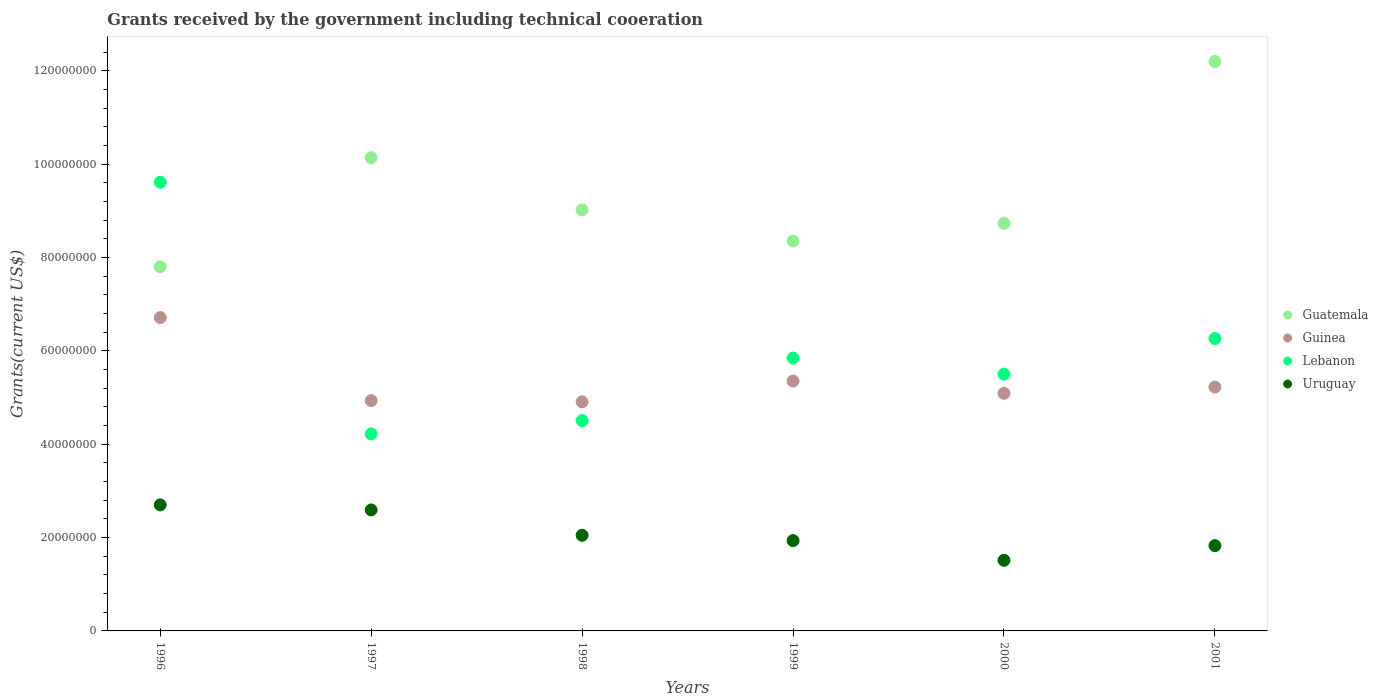How many different coloured dotlines are there?
Ensure brevity in your answer.  4. Is the number of dotlines equal to the number of legend labels?
Give a very brief answer. Yes. What is the total grants received by the government in Uruguay in 1996?
Provide a succinct answer. 2.70e+07. Across all years, what is the maximum total grants received by the government in Guatemala?
Provide a short and direct response. 1.22e+08. Across all years, what is the minimum total grants received by the government in Lebanon?
Provide a short and direct response. 4.22e+07. What is the total total grants received by the government in Lebanon in the graph?
Offer a very short reply. 3.60e+08. What is the difference between the total grants received by the government in Lebanon in 1999 and that in 2000?
Offer a very short reply. 3.45e+06. What is the difference between the total grants received by the government in Guatemala in 1998 and the total grants received by the government in Lebanon in 1996?
Your answer should be compact. -5.93e+06. What is the average total grants received by the government in Guatemala per year?
Keep it short and to the point. 9.37e+07. In the year 2000, what is the difference between the total grants received by the government in Guatemala and total grants received by the government in Guinea?
Provide a short and direct response. 3.64e+07. In how many years, is the total grants received by the government in Uruguay greater than 72000000 US$?
Give a very brief answer. 0. What is the ratio of the total grants received by the government in Guatemala in 1997 to that in 2000?
Provide a short and direct response. 1.16. What is the difference between the highest and the second highest total grants received by the government in Guatemala?
Ensure brevity in your answer.  2.06e+07. What is the difference between the highest and the lowest total grants received by the government in Uruguay?
Provide a succinct answer. 1.19e+07. In how many years, is the total grants received by the government in Lebanon greater than the average total grants received by the government in Lebanon taken over all years?
Your response must be concise. 2. Is the sum of the total grants received by the government in Uruguay in 1998 and 2001 greater than the maximum total grants received by the government in Guatemala across all years?
Give a very brief answer. No. Is it the case that in every year, the sum of the total grants received by the government in Lebanon and total grants received by the government in Guinea  is greater than the sum of total grants received by the government in Uruguay and total grants received by the government in Guatemala?
Give a very brief answer. No. How many dotlines are there?
Make the answer very short. 4. What is the difference between two consecutive major ticks on the Y-axis?
Keep it short and to the point. 2.00e+07. Does the graph contain any zero values?
Keep it short and to the point. No. Does the graph contain grids?
Make the answer very short. No. How are the legend labels stacked?
Provide a short and direct response. Vertical. What is the title of the graph?
Make the answer very short. Grants received by the government including technical cooeration. Does "Jamaica" appear as one of the legend labels in the graph?
Your response must be concise. No. What is the label or title of the Y-axis?
Give a very brief answer. Grants(current US$). What is the Grants(current US$) in Guatemala in 1996?
Ensure brevity in your answer.  7.80e+07. What is the Grants(current US$) of Guinea in 1996?
Ensure brevity in your answer.  6.71e+07. What is the Grants(current US$) in Lebanon in 1996?
Offer a very short reply. 9.61e+07. What is the Grants(current US$) of Uruguay in 1996?
Make the answer very short. 2.70e+07. What is the Grants(current US$) of Guatemala in 1997?
Your answer should be very brief. 1.01e+08. What is the Grants(current US$) of Guinea in 1997?
Offer a very short reply. 4.93e+07. What is the Grants(current US$) of Lebanon in 1997?
Provide a succinct answer. 4.22e+07. What is the Grants(current US$) of Uruguay in 1997?
Give a very brief answer. 2.59e+07. What is the Grants(current US$) of Guatemala in 1998?
Ensure brevity in your answer.  9.02e+07. What is the Grants(current US$) in Guinea in 1998?
Your answer should be compact. 4.91e+07. What is the Grants(current US$) of Lebanon in 1998?
Offer a very short reply. 4.51e+07. What is the Grants(current US$) in Uruguay in 1998?
Provide a short and direct response. 2.05e+07. What is the Grants(current US$) in Guatemala in 1999?
Provide a short and direct response. 8.35e+07. What is the Grants(current US$) in Guinea in 1999?
Your answer should be very brief. 5.35e+07. What is the Grants(current US$) in Lebanon in 1999?
Provide a short and direct response. 5.85e+07. What is the Grants(current US$) in Uruguay in 1999?
Offer a very short reply. 1.94e+07. What is the Grants(current US$) of Guatemala in 2000?
Your response must be concise. 8.73e+07. What is the Grants(current US$) in Guinea in 2000?
Give a very brief answer. 5.09e+07. What is the Grants(current US$) of Lebanon in 2000?
Your answer should be very brief. 5.50e+07. What is the Grants(current US$) in Uruguay in 2000?
Provide a succinct answer. 1.51e+07. What is the Grants(current US$) in Guatemala in 2001?
Your answer should be compact. 1.22e+08. What is the Grants(current US$) of Guinea in 2001?
Offer a very short reply. 5.22e+07. What is the Grants(current US$) in Lebanon in 2001?
Your answer should be very brief. 6.26e+07. What is the Grants(current US$) in Uruguay in 2001?
Offer a very short reply. 1.83e+07. Across all years, what is the maximum Grants(current US$) of Guatemala?
Ensure brevity in your answer.  1.22e+08. Across all years, what is the maximum Grants(current US$) in Guinea?
Provide a succinct answer. 6.71e+07. Across all years, what is the maximum Grants(current US$) of Lebanon?
Make the answer very short. 9.61e+07. Across all years, what is the maximum Grants(current US$) of Uruguay?
Give a very brief answer. 2.70e+07. Across all years, what is the minimum Grants(current US$) in Guatemala?
Your response must be concise. 7.80e+07. Across all years, what is the minimum Grants(current US$) in Guinea?
Offer a very short reply. 4.91e+07. Across all years, what is the minimum Grants(current US$) in Lebanon?
Offer a very short reply. 4.22e+07. Across all years, what is the minimum Grants(current US$) in Uruguay?
Your answer should be compact. 1.51e+07. What is the total Grants(current US$) in Guatemala in the graph?
Offer a terse response. 5.62e+08. What is the total Grants(current US$) of Guinea in the graph?
Your answer should be compact. 3.22e+08. What is the total Grants(current US$) in Lebanon in the graph?
Give a very brief answer. 3.60e+08. What is the total Grants(current US$) in Uruguay in the graph?
Make the answer very short. 1.26e+08. What is the difference between the Grants(current US$) in Guatemala in 1996 and that in 1997?
Provide a short and direct response. -2.34e+07. What is the difference between the Grants(current US$) of Guinea in 1996 and that in 1997?
Your answer should be very brief. 1.78e+07. What is the difference between the Grants(current US$) of Lebanon in 1996 and that in 1997?
Provide a short and direct response. 5.39e+07. What is the difference between the Grants(current US$) in Uruguay in 1996 and that in 1997?
Make the answer very short. 1.08e+06. What is the difference between the Grants(current US$) of Guatemala in 1996 and that in 1998?
Give a very brief answer. -1.22e+07. What is the difference between the Grants(current US$) of Guinea in 1996 and that in 1998?
Offer a very short reply. 1.80e+07. What is the difference between the Grants(current US$) of Lebanon in 1996 and that in 1998?
Give a very brief answer. 5.11e+07. What is the difference between the Grants(current US$) in Uruguay in 1996 and that in 1998?
Provide a short and direct response. 6.51e+06. What is the difference between the Grants(current US$) in Guatemala in 1996 and that in 1999?
Offer a very short reply. -5.51e+06. What is the difference between the Grants(current US$) of Guinea in 1996 and that in 1999?
Provide a succinct answer. 1.36e+07. What is the difference between the Grants(current US$) in Lebanon in 1996 and that in 1999?
Provide a succinct answer. 3.77e+07. What is the difference between the Grants(current US$) of Uruguay in 1996 and that in 1999?
Offer a terse response. 7.65e+06. What is the difference between the Grants(current US$) of Guatemala in 1996 and that in 2000?
Offer a very short reply. -9.30e+06. What is the difference between the Grants(current US$) in Guinea in 1996 and that in 2000?
Keep it short and to the point. 1.62e+07. What is the difference between the Grants(current US$) of Lebanon in 1996 and that in 2000?
Your answer should be very brief. 4.11e+07. What is the difference between the Grants(current US$) of Uruguay in 1996 and that in 2000?
Make the answer very short. 1.19e+07. What is the difference between the Grants(current US$) in Guatemala in 1996 and that in 2001?
Ensure brevity in your answer.  -4.40e+07. What is the difference between the Grants(current US$) of Guinea in 1996 and that in 2001?
Ensure brevity in your answer.  1.49e+07. What is the difference between the Grants(current US$) in Lebanon in 1996 and that in 2001?
Offer a terse response. 3.35e+07. What is the difference between the Grants(current US$) of Uruguay in 1996 and that in 2001?
Your response must be concise. 8.73e+06. What is the difference between the Grants(current US$) in Guatemala in 1997 and that in 1998?
Make the answer very short. 1.12e+07. What is the difference between the Grants(current US$) of Guinea in 1997 and that in 1998?
Your answer should be compact. 2.60e+05. What is the difference between the Grants(current US$) of Lebanon in 1997 and that in 1998?
Provide a succinct answer. -2.85e+06. What is the difference between the Grants(current US$) in Uruguay in 1997 and that in 1998?
Your response must be concise. 5.43e+06. What is the difference between the Grants(current US$) in Guatemala in 1997 and that in 1999?
Your answer should be compact. 1.78e+07. What is the difference between the Grants(current US$) of Guinea in 1997 and that in 1999?
Provide a succinct answer. -4.19e+06. What is the difference between the Grants(current US$) in Lebanon in 1997 and that in 1999?
Keep it short and to the point. -1.63e+07. What is the difference between the Grants(current US$) in Uruguay in 1997 and that in 1999?
Give a very brief answer. 6.57e+06. What is the difference between the Grants(current US$) of Guatemala in 1997 and that in 2000?
Provide a short and direct response. 1.41e+07. What is the difference between the Grants(current US$) of Guinea in 1997 and that in 2000?
Offer a very short reply. -1.56e+06. What is the difference between the Grants(current US$) of Lebanon in 1997 and that in 2000?
Your response must be concise. -1.28e+07. What is the difference between the Grants(current US$) of Uruguay in 1997 and that in 2000?
Your answer should be compact. 1.08e+07. What is the difference between the Grants(current US$) in Guatemala in 1997 and that in 2001?
Provide a short and direct response. -2.06e+07. What is the difference between the Grants(current US$) in Guinea in 1997 and that in 2001?
Provide a short and direct response. -2.91e+06. What is the difference between the Grants(current US$) in Lebanon in 1997 and that in 2001?
Give a very brief answer. -2.04e+07. What is the difference between the Grants(current US$) in Uruguay in 1997 and that in 2001?
Your response must be concise. 7.65e+06. What is the difference between the Grants(current US$) of Guatemala in 1998 and that in 1999?
Give a very brief answer. 6.67e+06. What is the difference between the Grants(current US$) in Guinea in 1998 and that in 1999?
Offer a very short reply. -4.45e+06. What is the difference between the Grants(current US$) in Lebanon in 1998 and that in 1999?
Your answer should be compact. -1.34e+07. What is the difference between the Grants(current US$) in Uruguay in 1998 and that in 1999?
Provide a succinct answer. 1.14e+06. What is the difference between the Grants(current US$) of Guatemala in 1998 and that in 2000?
Give a very brief answer. 2.88e+06. What is the difference between the Grants(current US$) in Guinea in 1998 and that in 2000?
Your response must be concise. -1.82e+06. What is the difference between the Grants(current US$) of Lebanon in 1998 and that in 2000?
Keep it short and to the point. -9.96e+06. What is the difference between the Grants(current US$) in Uruguay in 1998 and that in 2000?
Give a very brief answer. 5.36e+06. What is the difference between the Grants(current US$) in Guatemala in 1998 and that in 2001?
Make the answer very short. -3.18e+07. What is the difference between the Grants(current US$) in Guinea in 1998 and that in 2001?
Make the answer very short. -3.17e+06. What is the difference between the Grants(current US$) in Lebanon in 1998 and that in 2001?
Keep it short and to the point. -1.76e+07. What is the difference between the Grants(current US$) of Uruguay in 1998 and that in 2001?
Offer a very short reply. 2.22e+06. What is the difference between the Grants(current US$) in Guatemala in 1999 and that in 2000?
Ensure brevity in your answer.  -3.79e+06. What is the difference between the Grants(current US$) of Guinea in 1999 and that in 2000?
Offer a very short reply. 2.63e+06. What is the difference between the Grants(current US$) in Lebanon in 1999 and that in 2000?
Ensure brevity in your answer.  3.45e+06. What is the difference between the Grants(current US$) of Uruguay in 1999 and that in 2000?
Offer a very short reply. 4.22e+06. What is the difference between the Grants(current US$) in Guatemala in 1999 and that in 2001?
Offer a terse response. -3.85e+07. What is the difference between the Grants(current US$) of Guinea in 1999 and that in 2001?
Offer a very short reply. 1.28e+06. What is the difference between the Grants(current US$) of Lebanon in 1999 and that in 2001?
Provide a succinct answer. -4.17e+06. What is the difference between the Grants(current US$) of Uruguay in 1999 and that in 2001?
Keep it short and to the point. 1.08e+06. What is the difference between the Grants(current US$) of Guatemala in 2000 and that in 2001?
Make the answer very short. -3.47e+07. What is the difference between the Grants(current US$) in Guinea in 2000 and that in 2001?
Keep it short and to the point. -1.35e+06. What is the difference between the Grants(current US$) of Lebanon in 2000 and that in 2001?
Give a very brief answer. -7.62e+06. What is the difference between the Grants(current US$) in Uruguay in 2000 and that in 2001?
Give a very brief answer. -3.14e+06. What is the difference between the Grants(current US$) in Guatemala in 1996 and the Grants(current US$) in Guinea in 1997?
Offer a very short reply. 2.87e+07. What is the difference between the Grants(current US$) of Guatemala in 1996 and the Grants(current US$) of Lebanon in 1997?
Your answer should be compact. 3.58e+07. What is the difference between the Grants(current US$) in Guatemala in 1996 and the Grants(current US$) in Uruguay in 1997?
Ensure brevity in your answer.  5.21e+07. What is the difference between the Grants(current US$) in Guinea in 1996 and the Grants(current US$) in Lebanon in 1997?
Give a very brief answer. 2.49e+07. What is the difference between the Grants(current US$) of Guinea in 1996 and the Grants(current US$) of Uruguay in 1997?
Provide a succinct answer. 4.12e+07. What is the difference between the Grants(current US$) of Lebanon in 1996 and the Grants(current US$) of Uruguay in 1997?
Provide a short and direct response. 7.02e+07. What is the difference between the Grants(current US$) of Guatemala in 1996 and the Grants(current US$) of Guinea in 1998?
Offer a terse response. 2.89e+07. What is the difference between the Grants(current US$) in Guatemala in 1996 and the Grants(current US$) in Lebanon in 1998?
Your response must be concise. 3.30e+07. What is the difference between the Grants(current US$) in Guatemala in 1996 and the Grants(current US$) in Uruguay in 1998?
Your response must be concise. 5.75e+07. What is the difference between the Grants(current US$) of Guinea in 1996 and the Grants(current US$) of Lebanon in 1998?
Give a very brief answer. 2.21e+07. What is the difference between the Grants(current US$) in Guinea in 1996 and the Grants(current US$) in Uruguay in 1998?
Provide a succinct answer. 4.66e+07. What is the difference between the Grants(current US$) of Lebanon in 1996 and the Grants(current US$) of Uruguay in 1998?
Keep it short and to the point. 7.56e+07. What is the difference between the Grants(current US$) of Guatemala in 1996 and the Grants(current US$) of Guinea in 1999?
Your answer should be very brief. 2.45e+07. What is the difference between the Grants(current US$) of Guatemala in 1996 and the Grants(current US$) of Lebanon in 1999?
Offer a terse response. 1.96e+07. What is the difference between the Grants(current US$) of Guatemala in 1996 and the Grants(current US$) of Uruguay in 1999?
Offer a very short reply. 5.87e+07. What is the difference between the Grants(current US$) of Guinea in 1996 and the Grants(current US$) of Lebanon in 1999?
Keep it short and to the point. 8.66e+06. What is the difference between the Grants(current US$) of Guinea in 1996 and the Grants(current US$) of Uruguay in 1999?
Offer a very short reply. 4.78e+07. What is the difference between the Grants(current US$) of Lebanon in 1996 and the Grants(current US$) of Uruguay in 1999?
Your answer should be very brief. 7.68e+07. What is the difference between the Grants(current US$) of Guatemala in 1996 and the Grants(current US$) of Guinea in 2000?
Offer a very short reply. 2.71e+07. What is the difference between the Grants(current US$) of Guatemala in 1996 and the Grants(current US$) of Lebanon in 2000?
Provide a succinct answer. 2.30e+07. What is the difference between the Grants(current US$) in Guatemala in 1996 and the Grants(current US$) in Uruguay in 2000?
Your answer should be very brief. 6.29e+07. What is the difference between the Grants(current US$) of Guinea in 1996 and the Grants(current US$) of Lebanon in 2000?
Make the answer very short. 1.21e+07. What is the difference between the Grants(current US$) in Guinea in 1996 and the Grants(current US$) in Uruguay in 2000?
Provide a short and direct response. 5.20e+07. What is the difference between the Grants(current US$) of Lebanon in 1996 and the Grants(current US$) of Uruguay in 2000?
Ensure brevity in your answer.  8.10e+07. What is the difference between the Grants(current US$) of Guatemala in 1996 and the Grants(current US$) of Guinea in 2001?
Your response must be concise. 2.58e+07. What is the difference between the Grants(current US$) in Guatemala in 1996 and the Grants(current US$) in Lebanon in 2001?
Your answer should be compact. 1.54e+07. What is the difference between the Grants(current US$) in Guatemala in 1996 and the Grants(current US$) in Uruguay in 2001?
Your answer should be very brief. 5.98e+07. What is the difference between the Grants(current US$) in Guinea in 1996 and the Grants(current US$) in Lebanon in 2001?
Your response must be concise. 4.49e+06. What is the difference between the Grants(current US$) in Guinea in 1996 and the Grants(current US$) in Uruguay in 2001?
Provide a short and direct response. 4.89e+07. What is the difference between the Grants(current US$) of Lebanon in 1996 and the Grants(current US$) of Uruguay in 2001?
Keep it short and to the point. 7.79e+07. What is the difference between the Grants(current US$) in Guatemala in 1997 and the Grants(current US$) in Guinea in 1998?
Offer a very short reply. 5.23e+07. What is the difference between the Grants(current US$) in Guatemala in 1997 and the Grants(current US$) in Lebanon in 1998?
Make the answer very short. 5.63e+07. What is the difference between the Grants(current US$) of Guatemala in 1997 and the Grants(current US$) of Uruguay in 1998?
Give a very brief answer. 8.09e+07. What is the difference between the Grants(current US$) in Guinea in 1997 and the Grants(current US$) in Lebanon in 1998?
Offer a terse response. 4.28e+06. What is the difference between the Grants(current US$) in Guinea in 1997 and the Grants(current US$) in Uruguay in 1998?
Your answer should be very brief. 2.88e+07. What is the difference between the Grants(current US$) in Lebanon in 1997 and the Grants(current US$) in Uruguay in 1998?
Make the answer very short. 2.17e+07. What is the difference between the Grants(current US$) of Guatemala in 1997 and the Grants(current US$) of Guinea in 1999?
Make the answer very short. 4.78e+07. What is the difference between the Grants(current US$) of Guatemala in 1997 and the Grants(current US$) of Lebanon in 1999?
Offer a terse response. 4.29e+07. What is the difference between the Grants(current US$) in Guatemala in 1997 and the Grants(current US$) in Uruguay in 1999?
Offer a terse response. 8.20e+07. What is the difference between the Grants(current US$) in Guinea in 1997 and the Grants(current US$) in Lebanon in 1999?
Provide a short and direct response. -9.13e+06. What is the difference between the Grants(current US$) in Guinea in 1997 and the Grants(current US$) in Uruguay in 1999?
Make the answer very short. 3.00e+07. What is the difference between the Grants(current US$) of Lebanon in 1997 and the Grants(current US$) of Uruguay in 1999?
Make the answer very short. 2.29e+07. What is the difference between the Grants(current US$) of Guatemala in 1997 and the Grants(current US$) of Guinea in 2000?
Provide a short and direct response. 5.05e+07. What is the difference between the Grants(current US$) in Guatemala in 1997 and the Grants(current US$) in Lebanon in 2000?
Offer a terse response. 4.64e+07. What is the difference between the Grants(current US$) in Guatemala in 1997 and the Grants(current US$) in Uruguay in 2000?
Give a very brief answer. 8.62e+07. What is the difference between the Grants(current US$) in Guinea in 1997 and the Grants(current US$) in Lebanon in 2000?
Your response must be concise. -5.68e+06. What is the difference between the Grants(current US$) of Guinea in 1997 and the Grants(current US$) of Uruguay in 2000?
Ensure brevity in your answer.  3.42e+07. What is the difference between the Grants(current US$) in Lebanon in 1997 and the Grants(current US$) in Uruguay in 2000?
Provide a short and direct response. 2.71e+07. What is the difference between the Grants(current US$) of Guatemala in 1997 and the Grants(current US$) of Guinea in 2001?
Your answer should be compact. 4.91e+07. What is the difference between the Grants(current US$) of Guatemala in 1997 and the Grants(current US$) of Lebanon in 2001?
Provide a succinct answer. 3.87e+07. What is the difference between the Grants(current US$) in Guatemala in 1997 and the Grants(current US$) in Uruguay in 2001?
Make the answer very short. 8.31e+07. What is the difference between the Grants(current US$) in Guinea in 1997 and the Grants(current US$) in Lebanon in 2001?
Your answer should be very brief. -1.33e+07. What is the difference between the Grants(current US$) of Guinea in 1997 and the Grants(current US$) of Uruguay in 2001?
Provide a succinct answer. 3.11e+07. What is the difference between the Grants(current US$) of Lebanon in 1997 and the Grants(current US$) of Uruguay in 2001?
Make the answer very short. 2.39e+07. What is the difference between the Grants(current US$) of Guatemala in 1998 and the Grants(current US$) of Guinea in 1999?
Offer a very short reply. 3.67e+07. What is the difference between the Grants(current US$) of Guatemala in 1998 and the Grants(current US$) of Lebanon in 1999?
Your response must be concise. 3.17e+07. What is the difference between the Grants(current US$) in Guatemala in 1998 and the Grants(current US$) in Uruguay in 1999?
Offer a terse response. 7.08e+07. What is the difference between the Grants(current US$) of Guinea in 1998 and the Grants(current US$) of Lebanon in 1999?
Ensure brevity in your answer.  -9.39e+06. What is the difference between the Grants(current US$) of Guinea in 1998 and the Grants(current US$) of Uruguay in 1999?
Ensure brevity in your answer.  2.97e+07. What is the difference between the Grants(current US$) in Lebanon in 1998 and the Grants(current US$) in Uruguay in 1999?
Offer a very short reply. 2.57e+07. What is the difference between the Grants(current US$) in Guatemala in 1998 and the Grants(current US$) in Guinea in 2000?
Give a very brief answer. 3.93e+07. What is the difference between the Grants(current US$) in Guatemala in 1998 and the Grants(current US$) in Lebanon in 2000?
Make the answer very short. 3.52e+07. What is the difference between the Grants(current US$) of Guatemala in 1998 and the Grants(current US$) of Uruguay in 2000?
Provide a succinct answer. 7.51e+07. What is the difference between the Grants(current US$) in Guinea in 1998 and the Grants(current US$) in Lebanon in 2000?
Your answer should be very brief. -5.94e+06. What is the difference between the Grants(current US$) of Guinea in 1998 and the Grants(current US$) of Uruguay in 2000?
Provide a short and direct response. 3.40e+07. What is the difference between the Grants(current US$) of Lebanon in 1998 and the Grants(current US$) of Uruguay in 2000?
Provide a succinct answer. 2.99e+07. What is the difference between the Grants(current US$) of Guatemala in 1998 and the Grants(current US$) of Guinea in 2001?
Offer a very short reply. 3.80e+07. What is the difference between the Grants(current US$) in Guatemala in 1998 and the Grants(current US$) in Lebanon in 2001?
Offer a very short reply. 2.76e+07. What is the difference between the Grants(current US$) in Guatemala in 1998 and the Grants(current US$) in Uruguay in 2001?
Provide a succinct answer. 7.19e+07. What is the difference between the Grants(current US$) of Guinea in 1998 and the Grants(current US$) of Lebanon in 2001?
Give a very brief answer. -1.36e+07. What is the difference between the Grants(current US$) of Guinea in 1998 and the Grants(current US$) of Uruguay in 2001?
Offer a terse response. 3.08e+07. What is the difference between the Grants(current US$) of Lebanon in 1998 and the Grants(current US$) of Uruguay in 2001?
Offer a terse response. 2.68e+07. What is the difference between the Grants(current US$) of Guatemala in 1999 and the Grants(current US$) of Guinea in 2000?
Your answer should be compact. 3.26e+07. What is the difference between the Grants(current US$) in Guatemala in 1999 and the Grants(current US$) in Lebanon in 2000?
Make the answer very short. 2.85e+07. What is the difference between the Grants(current US$) of Guatemala in 1999 and the Grants(current US$) of Uruguay in 2000?
Offer a terse response. 6.84e+07. What is the difference between the Grants(current US$) of Guinea in 1999 and the Grants(current US$) of Lebanon in 2000?
Your answer should be very brief. -1.49e+06. What is the difference between the Grants(current US$) of Guinea in 1999 and the Grants(current US$) of Uruguay in 2000?
Your response must be concise. 3.84e+07. What is the difference between the Grants(current US$) of Lebanon in 1999 and the Grants(current US$) of Uruguay in 2000?
Your answer should be compact. 4.33e+07. What is the difference between the Grants(current US$) in Guatemala in 1999 and the Grants(current US$) in Guinea in 2001?
Provide a succinct answer. 3.13e+07. What is the difference between the Grants(current US$) of Guatemala in 1999 and the Grants(current US$) of Lebanon in 2001?
Provide a short and direct response. 2.09e+07. What is the difference between the Grants(current US$) of Guatemala in 1999 and the Grants(current US$) of Uruguay in 2001?
Offer a terse response. 6.53e+07. What is the difference between the Grants(current US$) of Guinea in 1999 and the Grants(current US$) of Lebanon in 2001?
Your answer should be very brief. -9.11e+06. What is the difference between the Grants(current US$) of Guinea in 1999 and the Grants(current US$) of Uruguay in 2001?
Provide a short and direct response. 3.53e+07. What is the difference between the Grants(current US$) in Lebanon in 1999 and the Grants(current US$) in Uruguay in 2001?
Keep it short and to the point. 4.02e+07. What is the difference between the Grants(current US$) of Guatemala in 2000 and the Grants(current US$) of Guinea in 2001?
Your response must be concise. 3.51e+07. What is the difference between the Grants(current US$) of Guatemala in 2000 and the Grants(current US$) of Lebanon in 2001?
Your answer should be compact. 2.47e+07. What is the difference between the Grants(current US$) in Guatemala in 2000 and the Grants(current US$) in Uruguay in 2001?
Offer a very short reply. 6.90e+07. What is the difference between the Grants(current US$) in Guinea in 2000 and the Grants(current US$) in Lebanon in 2001?
Your answer should be compact. -1.17e+07. What is the difference between the Grants(current US$) in Guinea in 2000 and the Grants(current US$) in Uruguay in 2001?
Offer a terse response. 3.26e+07. What is the difference between the Grants(current US$) of Lebanon in 2000 and the Grants(current US$) of Uruguay in 2001?
Provide a short and direct response. 3.68e+07. What is the average Grants(current US$) of Guatemala per year?
Your answer should be compact. 9.37e+07. What is the average Grants(current US$) of Guinea per year?
Your answer should be compact. 5.37e+07. What is the average Grants(current US$) of Lebanon per year?
Your answer should be compact. 5.99e+07. What is the average Grants(current US$) in Uruguay per year?
Give a very brief answer. 2.10e+07. In the year 1996, what is the difference between the Grants(current US$) in Guatemala and Grants(current US$) in Guinea?
Provide a short and direct response. 1.09e+07. In the year 1996, what is the difference between the Grants(current US$) of Guatemala and Grants(current US$) of Lebanon?
Provide a short and direct response. -1.81e+07. In the year 1996, what is the difference between the Grants(current US$) of Guatemala and Grants(current US$) of Uruguay?
Your answer should be compact. 5.10e+07. In the year 1996, what is the difference between the Grants(current US$) of Guinea and Grants(current US$) of Lebanon?
Your answer should be compact. -2.90e+07. In the year 1996, what is the difference between the Grants(current US$) of Guinea and Grants(current US$) of Uruguay?
Your response must be concise. 4.01e+07. In the year 1996, what is the difference between the Grants(current US$) in Lebanon and Grants(current US$) in Uruguay?
Your response must be concise. 6.91e+07. In the year 1997, what is the difference between the Grants(current US$) in Guatemala and Grants(current US$) in Guinea?
Ensure brevity in your answer.  5.20e+07. In the year 1997, what is the difference between the Grants(current US$) in Guatemala and Grants(current US$) in Lebanon?
Your answer should be compact. 5.92e+07. In the year 1997, what is the difference between the Grants(current US$) in Guatemala and Grants(current US$) in Uruguay?
Your answer should be very brief. 7.55e+07. In the year 1997, what is the difference between the Grants(current US$) of Guinea and Grants(current US$) of Lebanon?
Your answer should be very brief. 7.13e+06. In the year 1997, what is the difference between the Grants(current US$) in Guinea and Grants(current US$) in Uruguay?
Make the answer very short. 2.34e+07. In the year 1997, what is the difference between the Grants(current US$) of Lebanon and Grants(current US$) of Uruguay?
Your answer should be very brief. 1.63e+07. In the year 1998, what is the difference between the Grants(current US$) of Guatemala and Grants(current US$) of Guinea?
Provide a short and direct response. 4.11e+07. In the year 1998, what is the difference between the Grants(current US$) in Guatemala and Grants(current US$) in Lebanon?
Ensure brevity in your answer.  4.51e+07. In the year 1998, what is the difference between the Grants(current US$) in Guatemala and Grants(current US$) in Uruguay?
Your answer should be compact. 6.97e+07. In the year 1998, what is the difference between the Grants(current US$) of Guinea and Grants(current US$) of Lebanon?
Offer a terse response. 4.02e+06. In the year 1998, what is the difference between the Grants(current US$) of Guinea and Grants(current US$) of Uruguay?
Make the answer very short. 2.86e+07. In the year 1998, what is the difference between the Grants(current US$) in Lebanon and Grants(current US$) in Uruguay?
Ensure brevity in your answer.  2.46e+07. In the year 1999, what is the difference between the Grants(current US$) of Guatemala and Grants(current US$) of Guinea?
Your answer should be compact. 3.00e+07. In the year 1999, what is the difference between the Grants(current US$) of Guatemala and Grants(current US$) of Lebanon?
Offer a terse response. 2.51e+07. In the year 1999, what is the difference between the Grants(current US$) of Guatemala and Grants(current US$) of Uruguay?
Offer a very short reply. 6.42e+07. In the year 1999, what is the difference between the Grants(current US$) in Guinea and Grants(current US$) in Lebanon?
Provide a succinct answer. -4.94e+06. In the year 1999, what is the difference between the Grants(current US$) in Guinea and Grants(current US$) in Uruguay?
Provide a succinct answer. 3.42e+07. In the year 1999, what is the difference between the Grants(current US$) of Lebanon and Grants(current US$) of Uruguay?
Your answer should be compact. 3.91e+07. In the year 2000, what is the difference between the Grants(current US$) in Guatemala and Grants(current US$) in Guinea?
Provide a succinct answer. 3.64e+07. In the year 2000, what is the difference between the Grants(current US$) of Guatemala and Grants(current US$) of Lebanon?
Offer a very short reply. 3.23e+07. In the year 2000, what is the difference between the Grants(current US$) in Guatemala and Grants(current US$) in Uruguay?
Offer a very short reply. 7.22e+07. In the year 2000, what is the difference between the Grants(current US$) of Guinea and Grants(current US$) of Lebanon?
Offer a very short reply. -4.12e+06. In the year 2000, what is the difference between the Grants(current US$) of Guinea and Grants(current US$) of Uruguay?
Offer a very short reply. 3.58e+07. In the year 2000, what is the difference between the Grants(current US$) of Lebanon and Grants(current US$) of Uruguay?
Offer a terse response. 3.99e+07. In the year 2001, what is the difference between the Grants(current US$) of Guatemala and Grants(current US$) of Guinea?
Make the answer very short. 6.97e+07. In the year 2001, what is the difference between the Grants(current US$) of Guatemala and Grants(current US$) of Lebanon?
Your answer should be very brief. 5.94e+07. In the year 2001, what is the difference between the Grants(current US$) in Guatemala and Grants(current US$) in Uruguay?
Your answer should be compact. 1.04e+08. In the year 2001, what is the difference between the Grants(current US$) of Guinea and Grants(current US$) of Lebanon?
Keep it short and to the point. -1.04e+07. In the year 2001, what is the difference between the Grants(current US$) in Guinea and Grants(current US$) in Uruguay?
Your answer should be compact. 3.40e+07. In the year 2001, what is the difference between the Grants(current US$) in Lebanon and Grants(current US$) in Uruguay?
Offer a very short reply. 4.44e+07. What is the ratio of the Grants(current US$) of Guatemala in 1996 to that in 1997?
Make the answer very short. 0.77. What is the ratio of the Grants(current US$) of Guinea in 1996 to that in 1997?
Keep it short and to the point. 1.36. What is the ratio of the Grants(current US$) of Lebanon in 1996 to that in 1997?
Give a very brief answer. 2.28. What is the ratio of the Grants(current US$) in Uruguay in 1996 to that in 1997?
Your response must be concise. 1.04. What is the ratio of the Grants(current US$) of Guatemala in 1996 to that in 1998?
Ensure brevity in your answer.  0.86. What is the ratio of the Grants(current US$) of Guinea in 1996 to that in 1998?
Offer a very short reply. 1.37. What is the ratio of the Grants(current US$) of Lebanon in 1996 to that in 1998?
Your answer should be very brief. 2.13. What is the ratio of the Grants(current US$) in Uruguay in 1996 to that in 1998?
Ensure brevity in your answer.  1.32. What is the ratio of the Grants(current US$) in Guatemala in 1996 to that in 1999?
Offer a very short reply. 0.93. What is the ratio of the Grants(current US$) of Guinea in 1996 to that in 1999?
Keep it short and to the point. 1.25. What is the ratio of the Grants(current US$) in Lebanon in 1996 to that in 1999?
Give a very brief answer. 1.64. What is the ratio of the Grants(current US$) in Uruguay in 1996 to that in 1999?
Your answer should be compact. 1.4. What is the ratio of the Grants(current US$) in Guatemala in 1996 to that in 2000?
Make the answer very short. 0.89. What is the ratio of the Grants(current US$) of Guinea in 1996 to that in 2000?
Offer a very short reply. 1.32. What is the ratio of the Grants(current US$) in Lebanon in 1996 to that in 2000?
Offer a terse response. 1.75. What is the ratio of the Grants(current US$) in Uruguay in 1996 to that in 2000?
Provide a succinct answer. 1.78. What is the ratio of the Grants(current US$) in Guatemala in 1996 to that in 2001?
Your answer should be very brief. 0.64. What is the ratio of the Grants(current US$) in Guinea in 1996 to that in 2001?
Make the answer very short. 1.28. What is the ratio of the Grants(current US$) in Lebanon in 1996 to that in 2001?
Provide a succinct answer. 1.53. What is the ratio of the Grants(current US$) in Uruguay in 1996 to that in 2001?
Provide a succinct answer. 1.48. What is the ratio of the Grants(current US$) of Guatemala in 1997 to that in 1998?
Offer a terse response. 1.12. What is the ratio of the Grants(current US$) of Lebanon in 1997 to that in 1998?
Your response must be concise. 0.94. What is the ratio of the Grants(current US$) in Uruguay in 1997 to that in 1998?
Give a very brief answer. 1.26. What is the ratio of the Grants(current US$) of Guatemala in 1997 to that in 1999?
Provide a short and direct response. 1.21. What is the ratio of the Grants(current US$) of Guinea in 1997 to that in 1999?
Provide a succinct answer. 0.92. What is the ratio of the Grants(current US$) of Lebanon in 1997 to that in 1999?
Provide a succinct answer. 0.72. What is the ratio of the Grants(current US$) in Uruguay in 1997 to that in 1999?
Offer a very short reply. 1.34. What is the ratio of the Grants(current US$) of Guatemala in 1997 to that in 2000?
Ensure brevity in your answer.  1.16. What is the ratio of the Grants(current US$) in Guinea in 1997 to that in 2000?
Keep it short and to the point. 0.97. What is the ratio of the Grants(current US$) in Lebanon in 1997 to that in 2000?
Ensure brevity in your answer.  0.77. What is the ratio of the Grants(current US$) in Uruguay in 1997 to that in 2000?
Keep it short and to the point. 1.71. What is the ratio of the Grants(current US$) of Guatemala in 1997 to that in 2001?
Offer a very short reply. 0.83. What is the ratio of the Grants(current US$) of Guinea in 1997 to that in 2001?
Your answer should be compact. 0.94. What is the ratio of the Grants(current US$) of Lebanon in 1997 to that in 2001?
Your answer should be compact. 0.67. What is the ratio of the Grants(current US$) of Uruguay in 1997 to that in 2001?
Provide a succinct answer. 1.42. What is the ratio of the Grants(current US$) of Guatemala in 1998 to that in 1999?
Your answer should be very brief. 1.08. What is the ratio of the Grants(current US$) of Guinea in 1998 to that in 1999?
Ensure brevity in your answer.  0.92. What is the ratio of the Grants(current US$) in Lebanon in 1998 to that in 1999?
Your response must be concise. 0.77. What is the ratio of the Grants(current US$) in Uruguay in 1998 to that in 1999?
Your answer should be compact. 1.06. What is the ratio of the Grants(current US$) of Guatemala in 1998 to that in 2000?
Your answer should be very brief. 1.03. What is the ratio of the Grants(current US$) in Guinea in 1998 to that in 2000?
Offer a very short reply. 0.96. What is the ratio of the Grants(current US$) in Lebanon in 1998 to that in 2000?
Your response must be concise. 0.82. What is the ratio of the Grants(current US$) in Uruguay in 1998 to that in 2000?
Offer a very short reply. 1.35. What is the ratio of the Grants(current US$) in Guatemala in 1998 to that in 2001?
Ensure brevity in your answer.  0.74. What is the ratio of the Grants(current US$) of Guinea in 1998 to that in 2001?
Give a very brief answer. 0.94. What is the ratio of the Grants(current US$) of Lebanon in 1998 to that in 2001?
Provide a succinct answer. 0.72. What is the ratio of the Grants(current US$) in Uruguay in 1998 to that in 2001?
Offer a terse response. 1.12. What is the ratio of the Grants(current US$) of Guatemala in 1999 to that in 2000?
Your response must be concise. 0.96. What is the ratio of the Grants(current US$) of Guinea in 1999 to that in 2000?
Offer a terse response. 1.05. What is the ratio of the Grants(current US$) of Lebanon in 1999 to that in 2000?
Provide a short and direct response. 1.06. What is the ratio of the Grants(current US$) in Uruguay in 1999 to that in 2000?
Give a very brief answer. 1.28. What is the ratio of the Grants(current US$) in Guatemala in 1999 to that in 2001?
Your response must be concise. 0.68. What is the ratio of the Grants(current US$) in Guinea in 1999 to that in 2001?
Provide a short and direct response. 1.02. What is the ratio of the Grants(current US$) of Lebanon in 1999 to that in 2001?
Give a very brief answer. 0.93. What is the ratio of the Grants(current US$) of Uruguay in 1999 to that in 2001?
Offer a very short reply. 1.06. What is the ratio of the Grants(current US$) of Guatemala in 2000 to that in 2001?
Give a very brief answer. 0.72. What is the ratio of the Grants(current US$) of Guinea in 2000 to that in 2001?
Ensure brevity in your answer.  0.97. What is the ratio of the Grants(current US$) in Lebanon in 2000 to that in 2001?
Offer a very short reply. 0.88. What is the ratio of the Grants(current US$) of Uruguay in 2000 to that in 2001?
Your answer should be compact. 0.83. What is the difference between the highest and the second highest Grants(current US$) in Guatemala?
Offer a terse response. 2.06e+07. What is the difference between the highest and the second highest Grants(current US$) of Guinea?
Give a very brief answer. 1.36e+07. What is the difference between the highest and the second highest Grants(current US$) of Lebanon?
Your answer should be very brief. 3.35e+07. What is the difference between the highest and the second highest Grants(current US$) in Uruguay?
Provide a succinct answer. 1.08e+06. What is the difference between the highest and the lowest Grants(current US$) of Guatemala?
Ensure brevity in your answer.  4.40e+07. What is the difference between the highest and the lowest Grants(current US$) of Guinea?
Your answer should be very brief. 1.80e+07. What is the difference between the highest and the lowest Grants(current US$) in Lebanon?
Your answer should be compact. 5.39e+07. What is the difference between the highest and the lowest Grants(current US$) of Uruguay?
Give a very brief answer. 1.19e+07. 